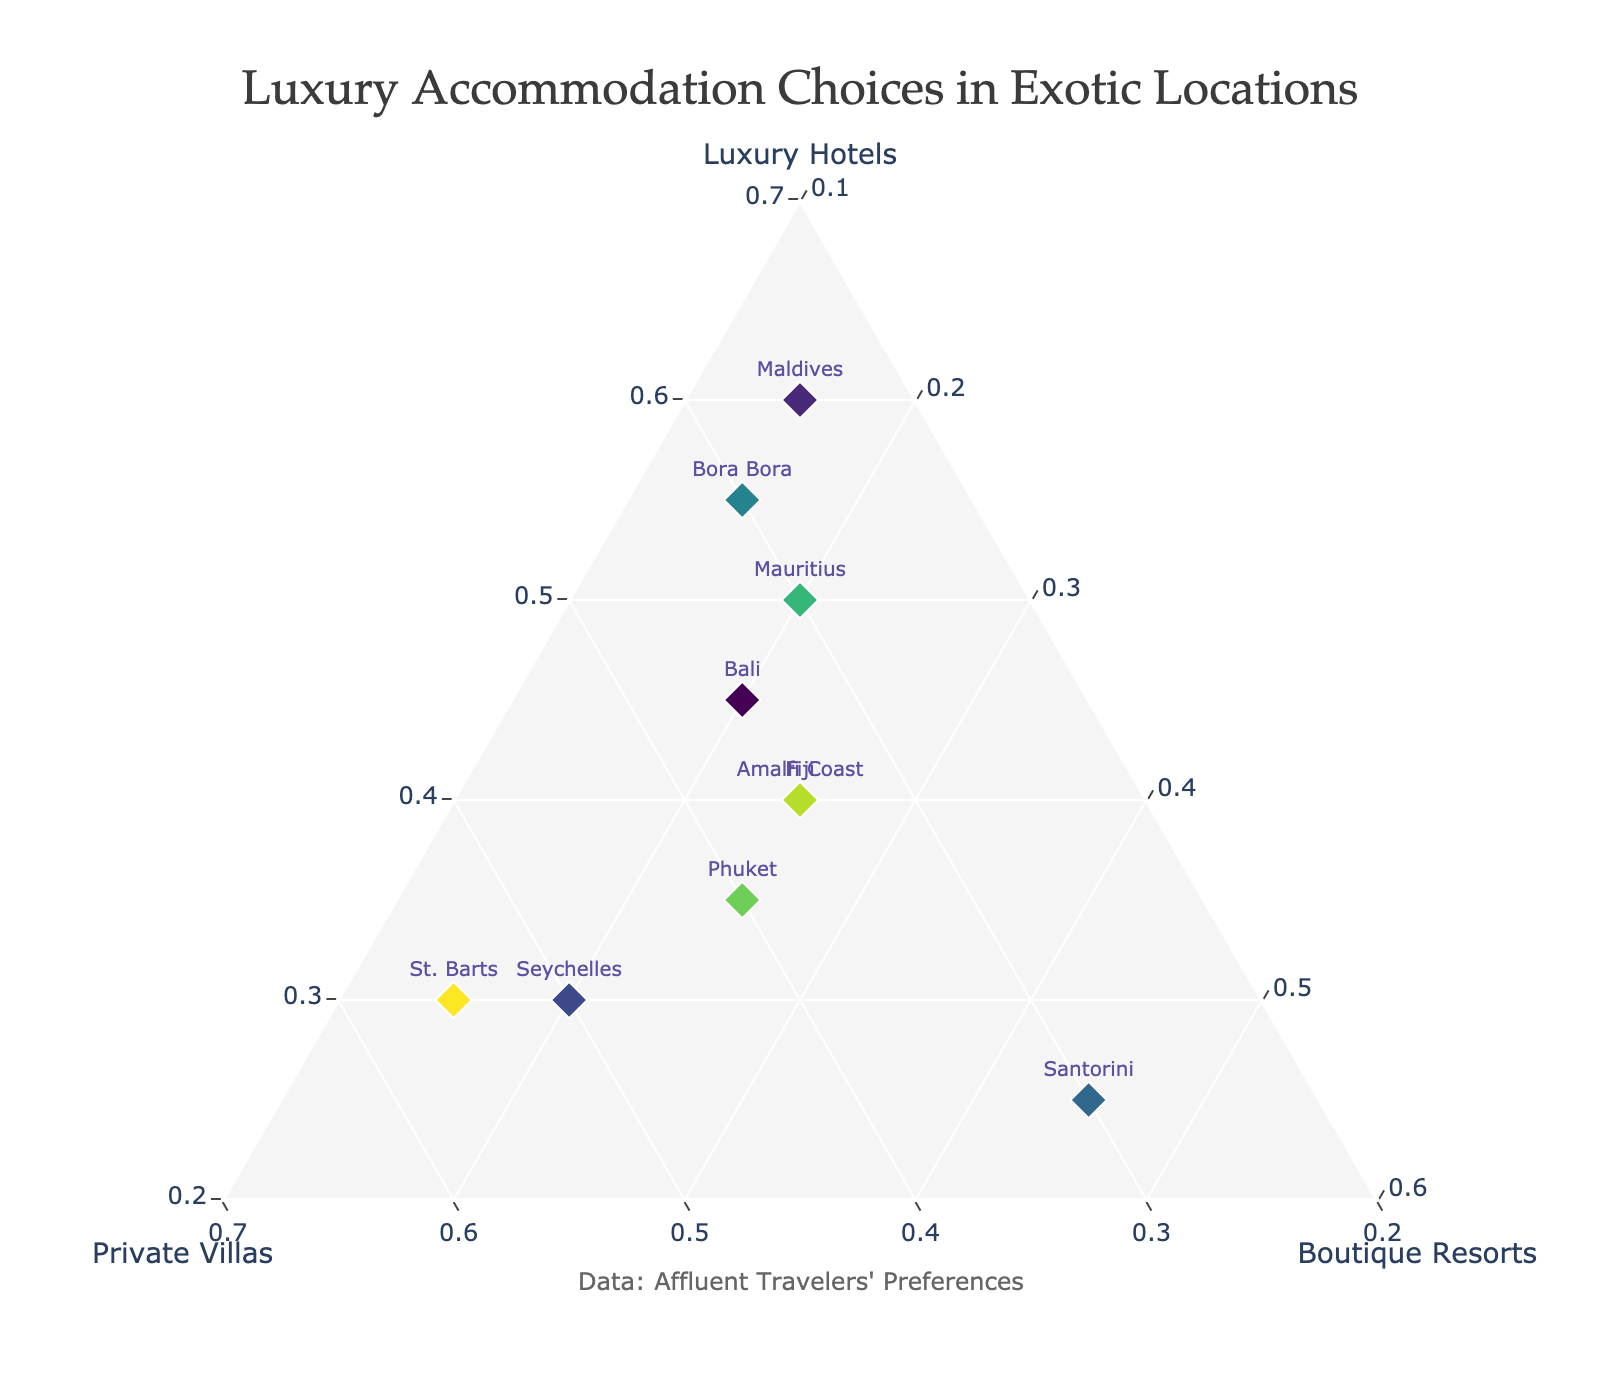Which location has the highest preference for boutique resorts? The figure shows the proportion of luxury hotels, private villas, and boutique resorts chosen in various locations. By looking at the compositional values for boutique resorts, Santorini has the highest value at 0.45.
Answer: Santorini How do the preferences for luxury hotels and private villas compare in the Maldives? In the figure, the Maldives has a preference of 0.60 for luxury hotels and 0.25 for private villas. Comparing these values, luxury hotels are preferred more than private villas.
Answer: Luxury hotels are preferred more What is the total proportion of luxury hotels and private villas in Bali? The figure shows Bali with a 0.45 proportion for luxury hotels and 0.35 for private villas. Summing these values gives 0.45 + 0.35 = 0.80.
Answer: 0.80 Which location has an equal preference for luxury hotels and private villas? By examining the values in the figure, St. Barts shows a higher preference for private villas (0.55) without an equal preference for luxury hotels (0.30). Checking again shows none of the locations have equal values for these categories.
Answer: None In Seychelles, how does the proportion of private villas compare to boutique resorts? Seychelles has a preference of 0.50 for private villas and 0.20 for boutique resorts. Comparing these values, private villas are preferred more than boutique resorts.
Answer: Private villas are preferred more Which location has a similar proportion for luxury hotels and boutique resorts? Bali shows a proportion of 0.45 for luxury hotels and 0.20 for boutique resorts, not equal. The closest is Fiji with 0.40 for luxury hotels and 0.25 for boutique resorts, still not equal. Answer: None.
Answer: None What is the combined preference for private villas in the Amalfi Coast and Santorini? From the figure, the Amalfi Coast has a 0.35 preference for private villas and Santorini has 0.30. Summing these values gives 0.35 + 0.30 = 0.65.
Answer: 0.65 Which location has the highest preference for luxury hotels? By examining the preferences for luxury hotels, Maldives has the highest value at 0.60.
Answer: Maldives How does the preference for private villas in Phuket compare to luxury hotels in Fiji? From the figure, Phuket's private villas have a preference of 0.40, while Fiji's luxury hotels have a preference of 0.40. Both preferences are equal at 0.40.
Answer: They are equal 